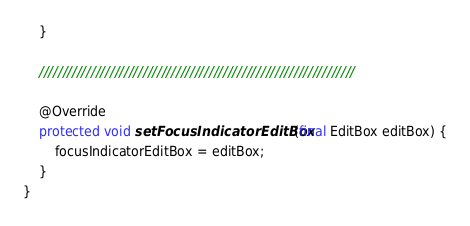Convert code to text. <code><loc_0><loc_0><loc_500><loc_500><_Java_>    }

    ///////////////////////////////////////////////////////////////////

    @Override
    protected void setFocusIndicatorEditBox(final EditBox editBox) {
        focusIndicatorEditBox = editBox;
    }
}
</code> 